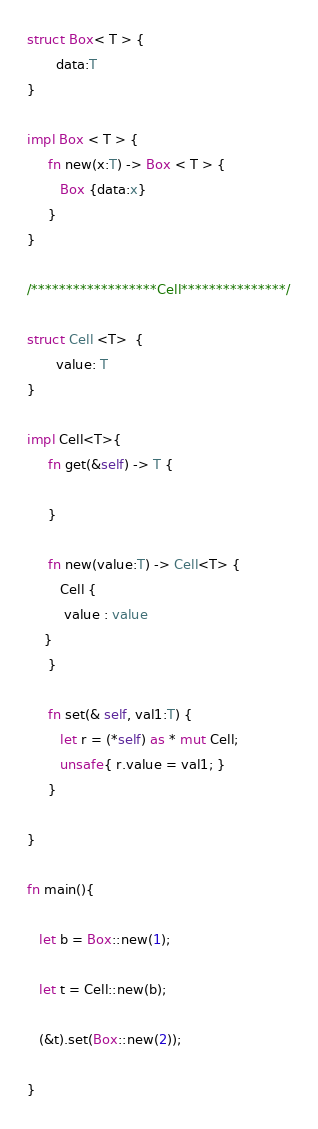<code> <loc_0><loc_0><loc_500><loc_500><_Rust_>

struct Box< T > {
       data:T
}

impl Box < T > {
     fn new(x:T) -> Box < T > {
     	Box {data:x}
     }
}

/******************Cell***************/

struct Cell <T>  {
       value: T
}

impl Cell<T>{
     fn get(&self) -> T {
 
     }

     fn new(value:T) -> Cell<T> {
     	Cell {
	     value : value
	}
     }

     fn set(& self, val1:T) {
     	let r = (*self) as * mut Cell;
     	unsafe{ r.value = val1; }
     }
     
}

fn main(){

   let b = Box::new(1);

   let t = Cell::new(b);

   (&t).set(Box::new(2));

}</code> 